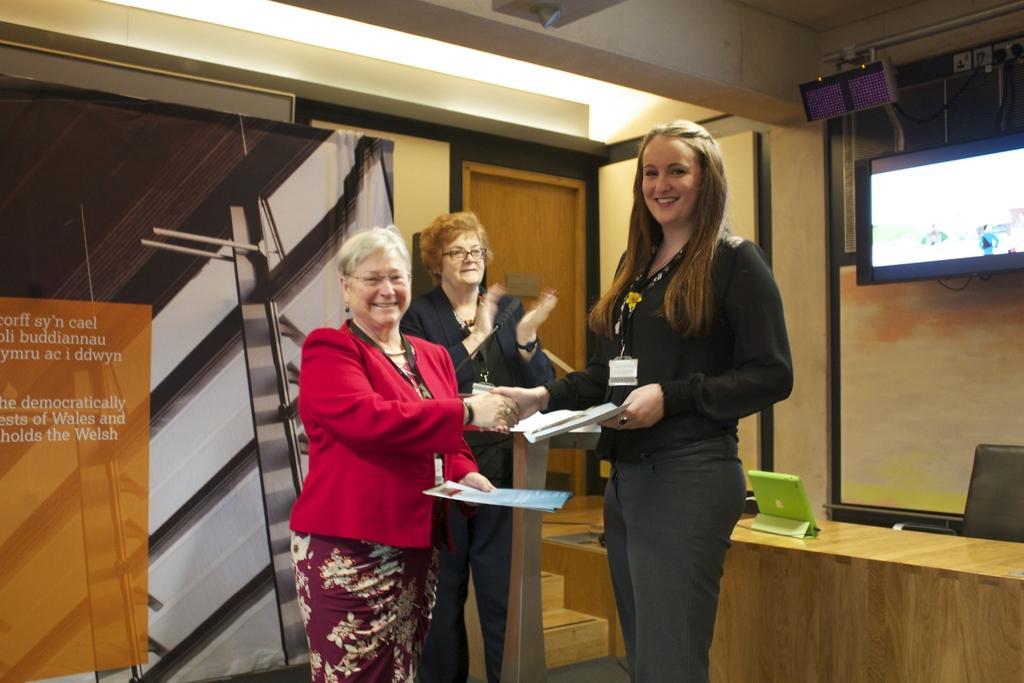In one or two sentences, can you explain what this image depicts? In this image we can see three women standing on the floor. The woman wearing red blazer is hand shaking with the woman opposite to her. In the background of the image we can see a I pod placed on the top of the table, television, podium and a banner. 